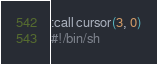Convert code to text. <code><loc_0><loc_0><loc_500><loc_500><_Bash_>:call cursor(3, 0)
#!/bin/sh



</code> 